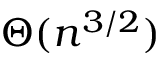Convert formula to latex. <formula><loc_0><loc_0><loc_500><loc_500>\Theta ( n ^ { 3 / 2 } )</formula> 